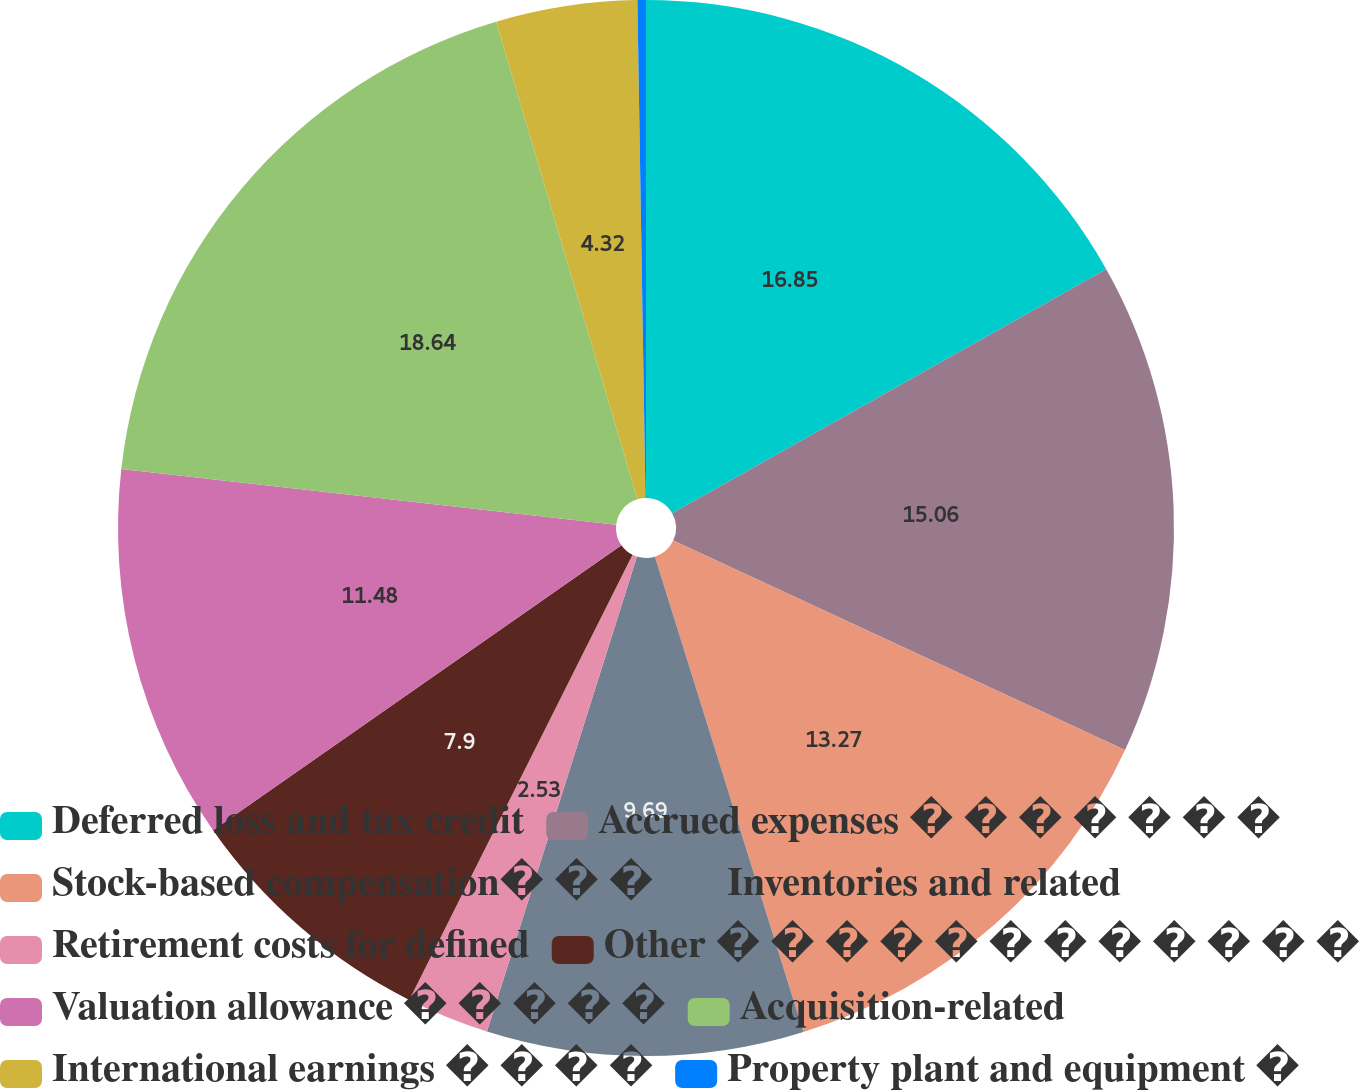<chart> <loc_0><loc_0><loc_500><loc_500><pie_chart><fcel>Deferred loss and tax credit<fcel>Accrued expenses � � � � � � �<fcel>Stock-based compensation� � �<fcel>Inventories and related<fcel>Retirement costs for defined<fcel>Other � � � � � � � � � � � �<fcel>Valuation allowance � � � � �<fcel>Acquisition-related<fcel>International earnings � � � �<fcel>Property plant and equipment �<nl><fcel>16.85%<fcel>15.06%<fcel>13.27%<fcel>9.69%<fcel>2.53%<fcel>7.9%<fcel>11.48%<fcel>18.64%<fcel>4.32%<fcel>0.26%<nl></chart> 